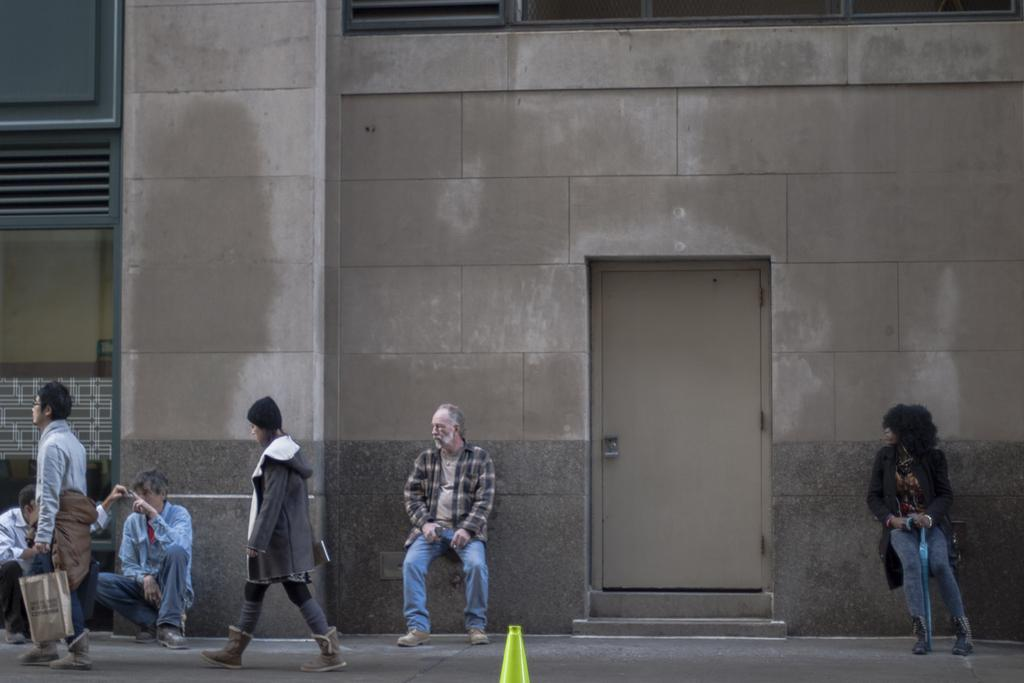What type of structure is present in the image? There is a building in the picture. What feature of the building is mentioned in the facts? The building has a door. What activities are the people in the image engaged in? Some people are walking, and some are sitting in the picture. What type of error can be seen in the picture? There is no mention of an error in the image, so it cannot be determined from the facts provided. 